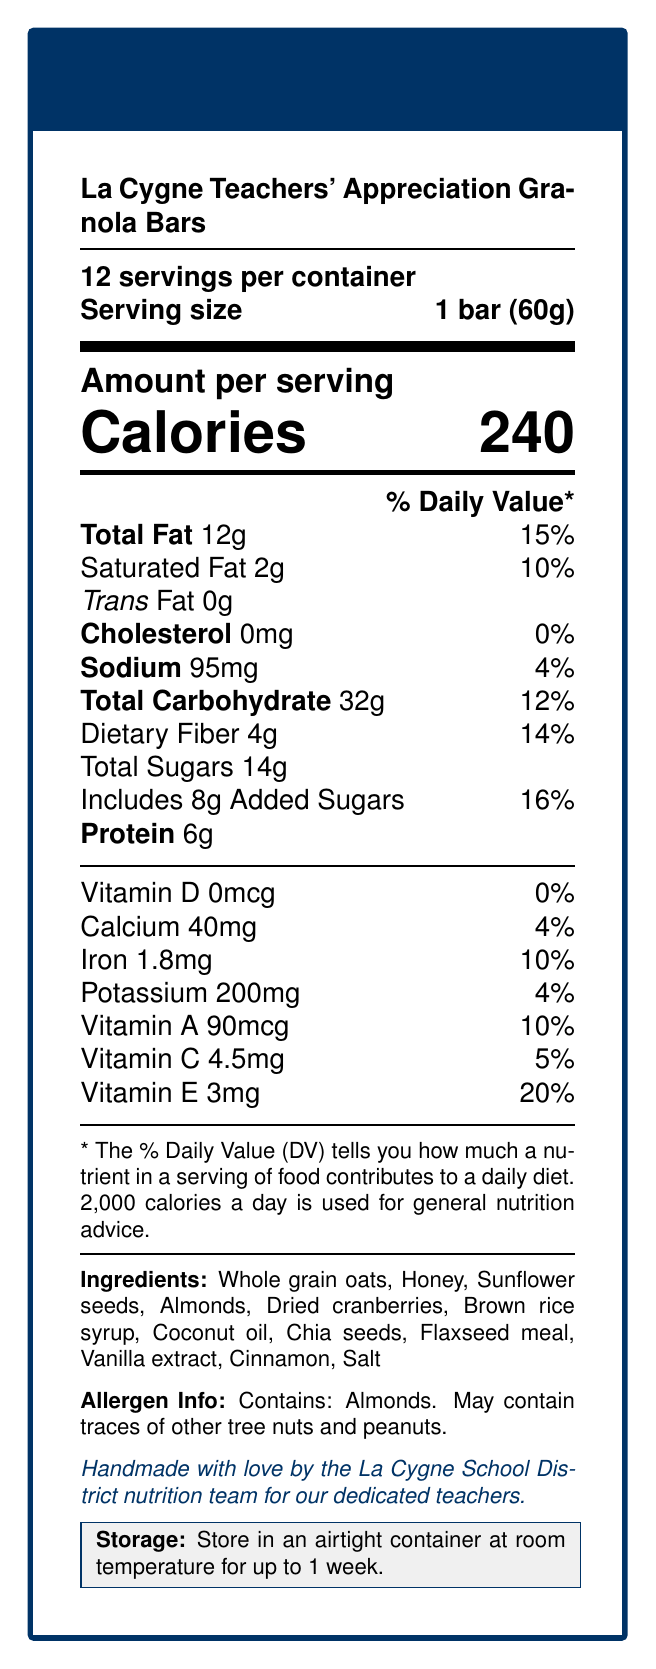what is the serving size of the La Cygne Teachers' Appreciation Granola Bars? The serving size is explicitly mentioned under the product name as "1 bar (60g)".
Answer: 1 bar (60g) how many servings are there per container? The document states "12 servings per container" right below the product name.
Answer: 12 how much protein does each granola bar contain? The protein content is listed under the nutritional information section as "Protein 6g".
Answer: 6g what is the daily value percentage of Vitamin E in each bar? The daily value percentage of Vitamin E is mentioned in the vitamin section as "Vitamin E 3mg 20%".
Answer: 20% what is the storage instruction for these granola bars? The storage instructions are provided at the bottom of the document highlighted in a light gray box.
Answer: Store in an airtight container at room temperature for up to 1 week. which ingredient is not an allergen or potential allergen? A. Almonds B. Sunflower seeds C. Tree nuts D. Peanuts The allergen info only mentions almonds and potential traces of other tree nuts and peanuts, not sunflower seeds.
Answer: B what is the main sweetener used in the granola bars? A. Sugar B. Honey C. Brown rice syrup D. Maple syrup Honey is listed as one of the ingredients, indicating it is used as a sweetener.
Answer: B does the document mention the presence of gluten in the granola bars? There is no mention of gluten or gluten-containing ingredients in the allergen information or the ingredient list.
Answer: No are these granola bars made by a commercial manufacturer? The document specifically states that they are "Handmade with love by the La Cygne School District nutrition team".
Answer: No summarize the main details provided in the document. This summary captures the key elements like nutritional information, ingredients, allergen information, and storage instructions.
Answer: The document gives the nutrition facts for the La Cygne Teachers' Appreciation Granola Bars. Each serving size is 1 bar (60g), with 12 servings per container. Key nutritional contents include 240 calories, 12g of total fat, 32g of carbohydrates, 6g of protein, and various vitamins. The bars contain almonds and may have traces of other nuts and peanuts. Ingredients listed include whole grain oats, honey, and more, and they should be stored in an airtight container at room temperature for up to a week. The granola bars are handmade by the La Cygne School District nutrition team for teacher appreciation. what is the manufacturing date of the granola bars? The manufacturing date is not provided in the document, so it cannot be determined.
Answer: Not enough information 